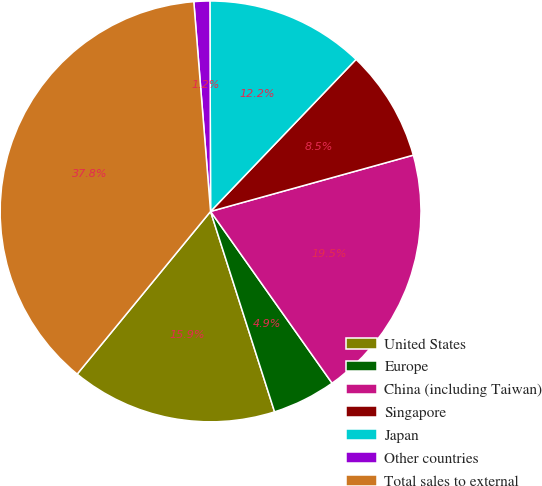Convert chart to OTSL. <chart><loc_0><loc_0><loc_500><loc_500><pie_chart><fcel>United States<fcel>Europe<fcel>China (including Taiwan)<fcel>Singapore<fcel>Japan<fcel>Other countries<fcel>Total sales to external<nl><fcel>15.85%<fcel>4.88%<fcel>19.51%<fcel>8.54%<fcel>12.2%<fcel>1.22%<fcel>37.8%<nl></chart> 